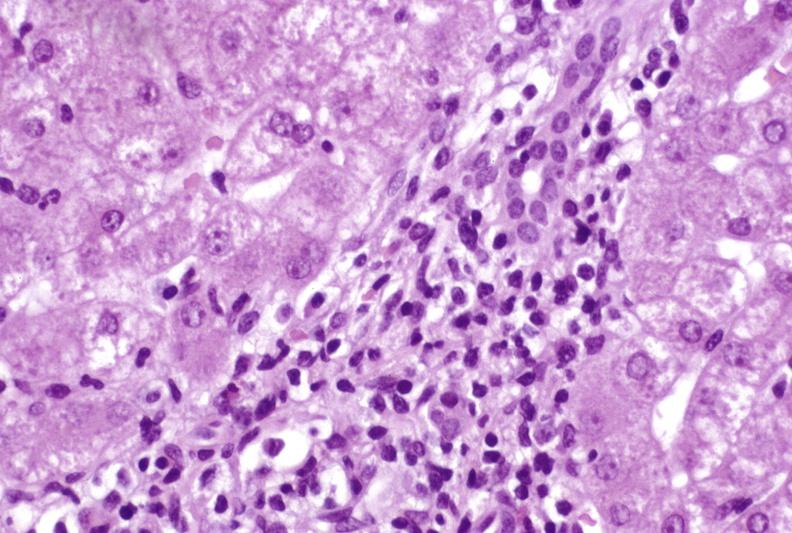s hemochromatosis present?
Answer the question using a single word or phrase. No 